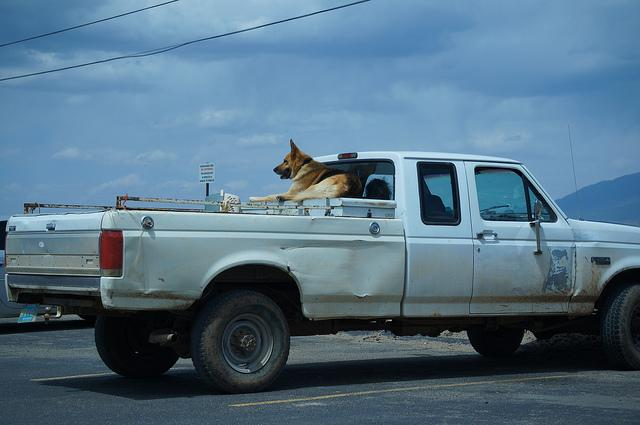Which truck does this dog's owner possess? Please explain your reasoning. white truck. It's a white truck 